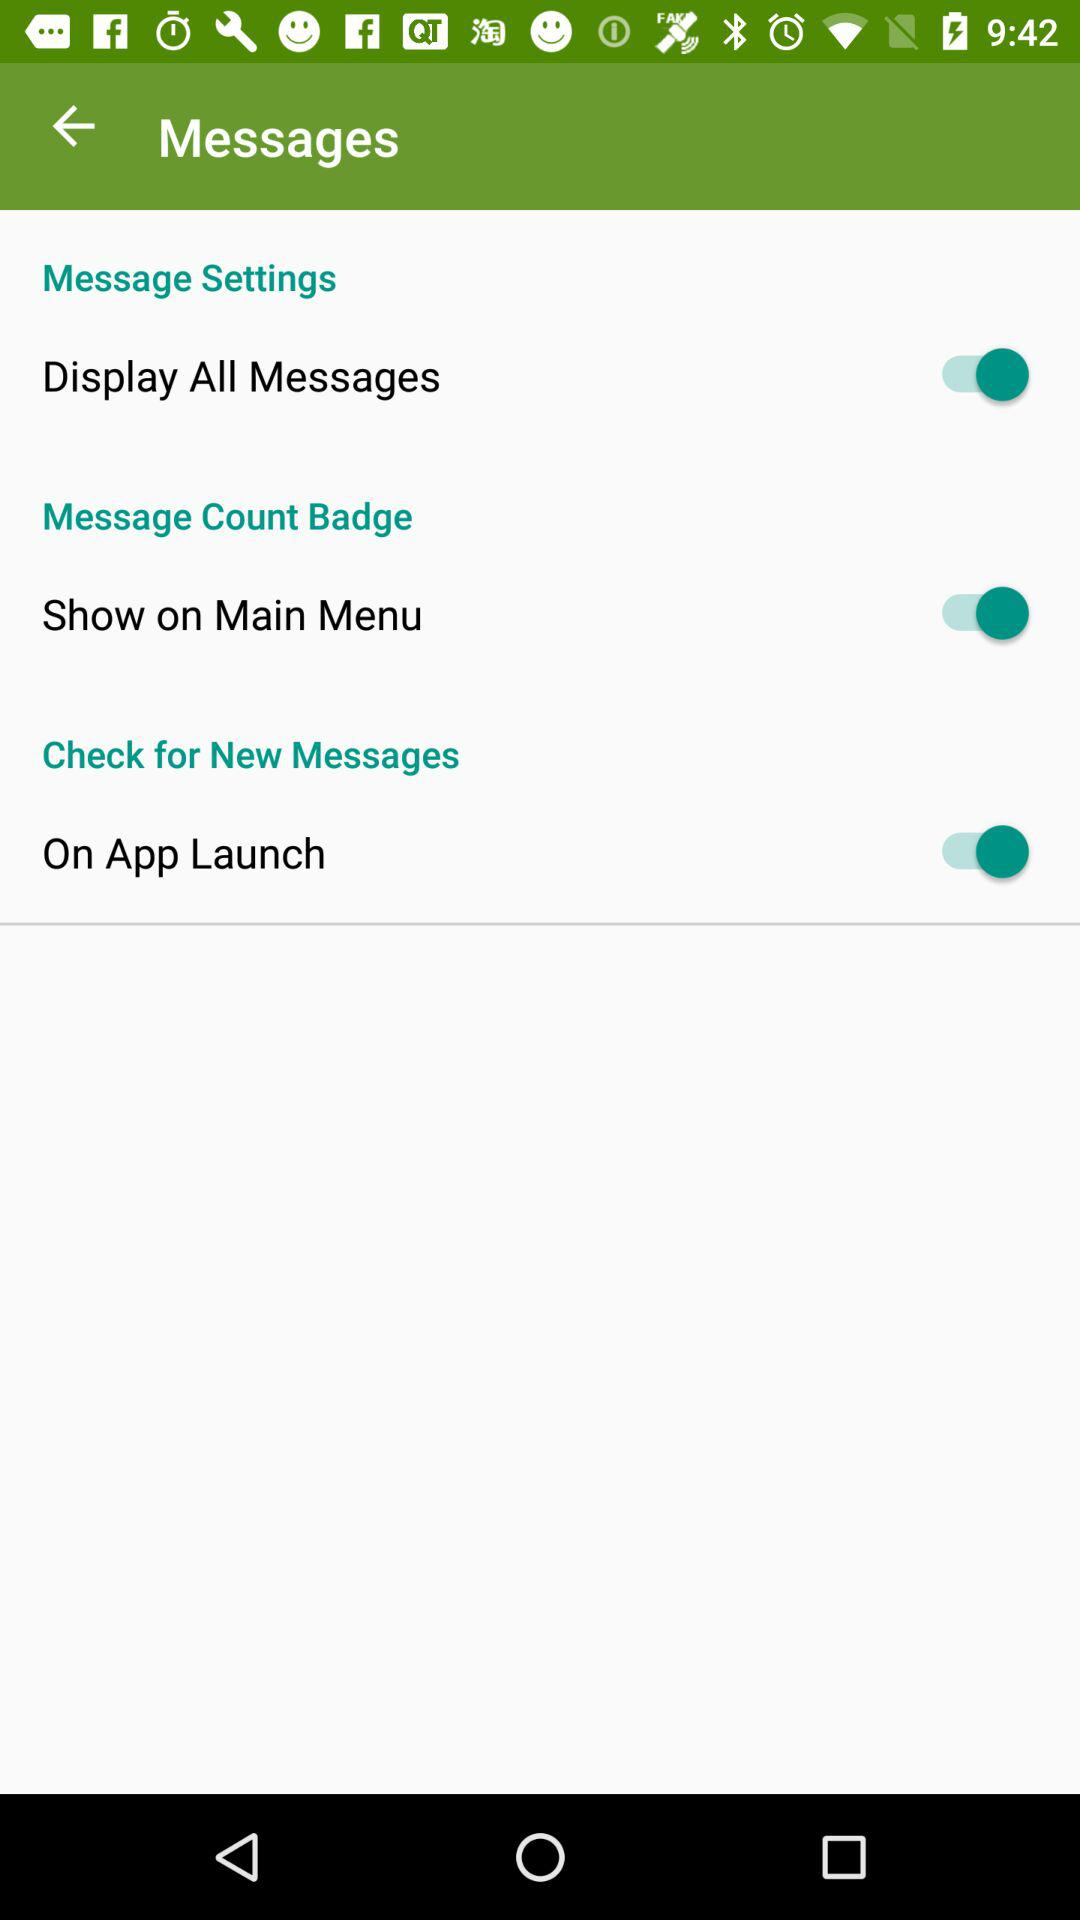What is the status of "On App Launch"? The status is "on". 